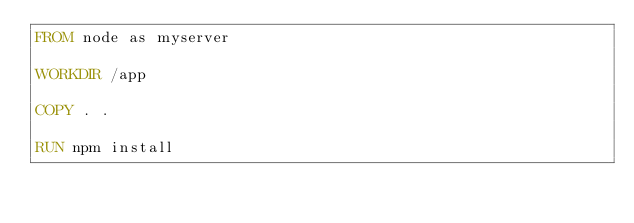Convert code to text. <code><loc_0><loc_0><loc_500><loc_500><_Dockerfile_>FROM node as myserver

WORKDIR /app

COPY . .

RUN npm install
</code> 